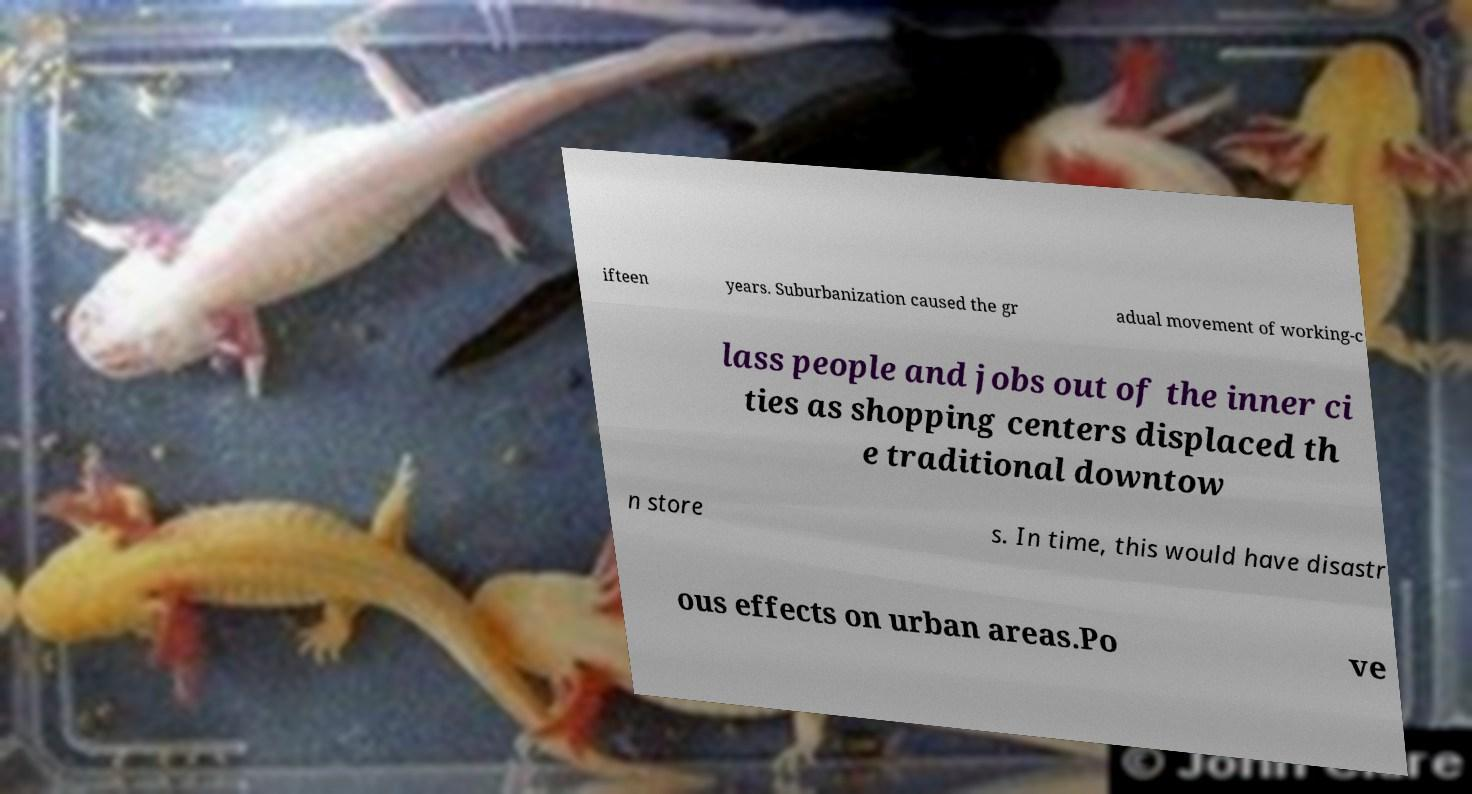Can you read and provide the text displayed in the image?This photo seems to have some interesting text. Can you extract and type it out for me? ifteen years. Suburbanization caused the gr adual movement of working-c lass people and jobs out of the inner ci ties as shopping centers displaced th e traditional downtow n store s. In time, this would have disastr ous effects on urban areas.Po ve 